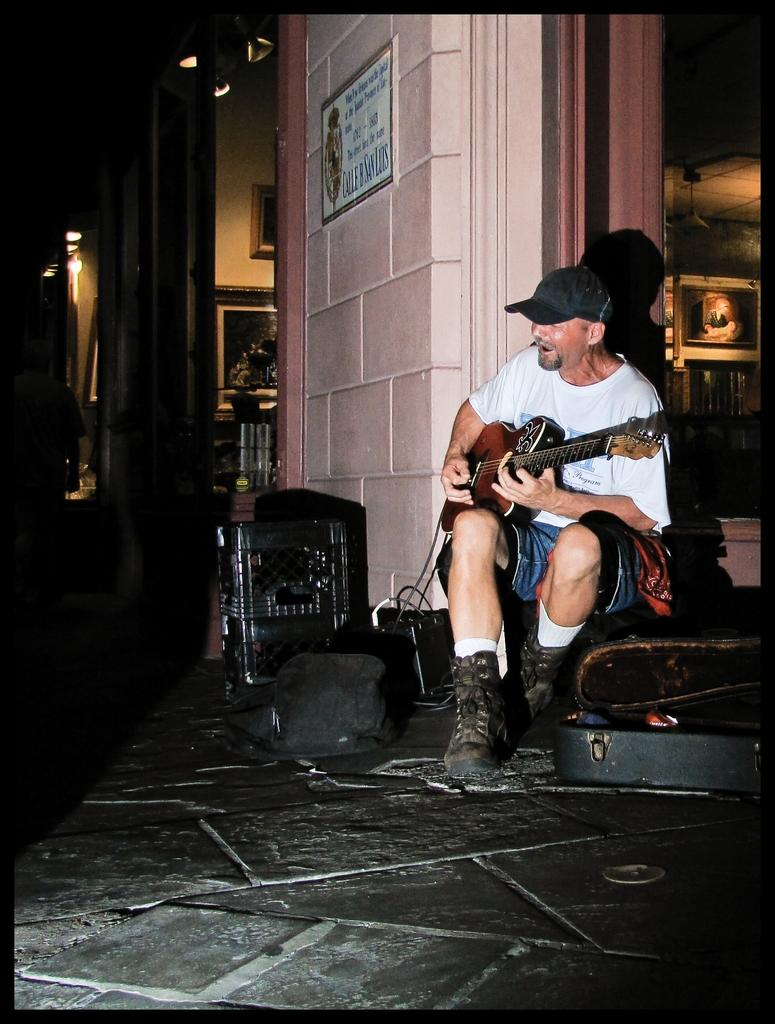What is the man in the image holding? The man is holding a guitar. What is the man doing with the guitar? The man is singing a song while holding the guitar. What is the man wearing on his upper body? The man is wearing a white t-shirt. What is the man wearing on his head? The man is wearing a cap. What is the man wearing on his feet? The man is wearing boots. What color is the wall behind the man? The wall is pink. How many frogs are sitting on the man's shoulder in the image? There are no frogs present in the image. What type of flower is growing on the man's cap in the image? There is no flower present on the man's cap in the image. 